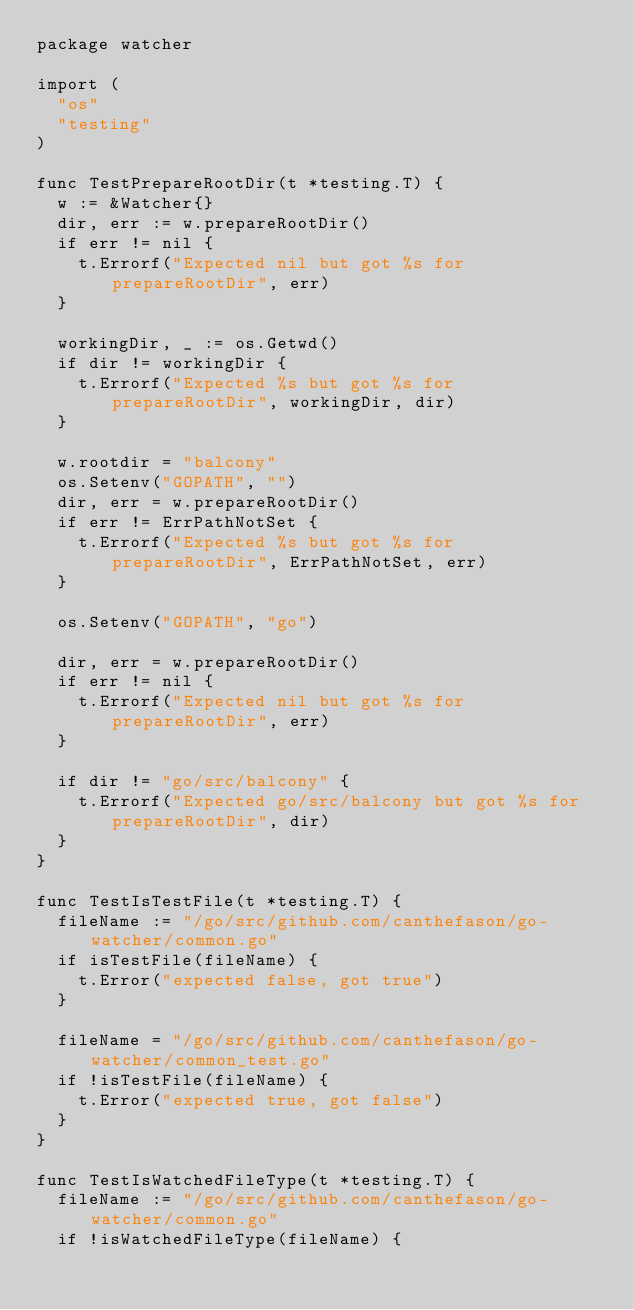Convert code to text. <code><loc_0><loc_0><loc_500><loc_500><_Go_>package watcher

import (
	"os"
	"testing"
)

func TestPrepareRootDir(t *testing.T) {
	w := &Watcher{}
	dir, err := w.prepareRootDir()
	if err != nil {
		t.Errorf("Expected nil but got %s for prepareRootDir", err)
	}

	workingDir, _ := os.Getwd()
	if dir != workingDir {
		t.Errorf("Expected %s but got %s for prepareRootDir", workingDir, dir)
	}

	w.rootdir = "balcony"
	os.Setenv("GOPATH", "")
	dir, err = w.prepareRootDir()
	if err != ErrPathNotSet {
		t.Errorf("Expected %s but got %s for prepareRootDir", ErrPathNotSet, err)
	}

	os.Setenv("GOPATH", "go")

	dir, err = w.prepareRootDir()
	if err != nil {
		t.Errorf("Expected nil but got %s for prepareRootDir", err)
	}

	if dir != "go/src/balcony" {
		t.Errorf("Expected go/src/balcony but got %s for prepareRootDir", dir)
	}
}

func TestIsTestFile(t *testing.T) {
	fileName := "/go/src/github.com/canthefason/go-watcher/common.go"
	if isTestFile(fileName) {
		t.Error("expected false, got true")
	}

	fileName = "/go/src/github.com/canthefason/go-watcher/common_test.go"
	if !isTestFile(fileName) {
		t.Error("expected true, got false")
	}
}

func TestIsWatchedFileType(t *testing.T) {
	fileName := "/go/src/github.com/canthefason/go-watcher/common.go"
	if !isWatchedFileType(fileName) {</code> 